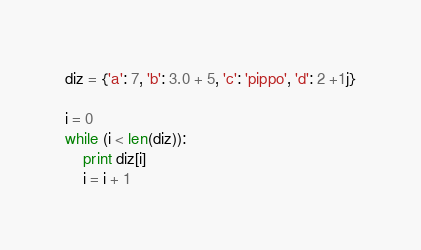<code> <loc_0><loc_0><loc_500><loc_500><_Python_>diz = {'a': 7, 'b': 3.0 + 5, 'c': 'pippo', 'd': 2 +1j}

i = 0
while (i < len(diz)):
    print diz[i]
    i = i + 1

</code> 